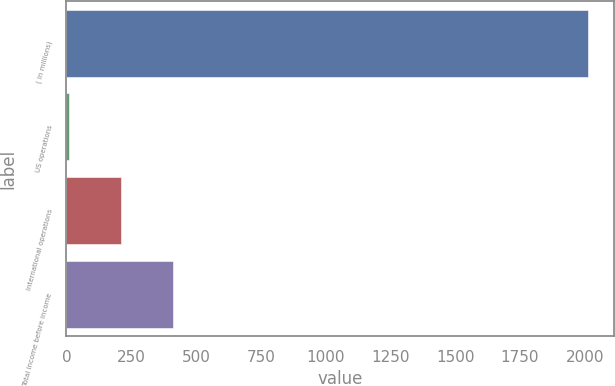<chart> <loc_0><loc_0><loc_500><loc_500><bar_chart><fcel>( in millions)<fcel>US operations<fcel>International operations<fcel>Total income before income<nl><fcel>2012<fcel>8.9<fcel>209.21<fcel>409.52<nl></chart> 